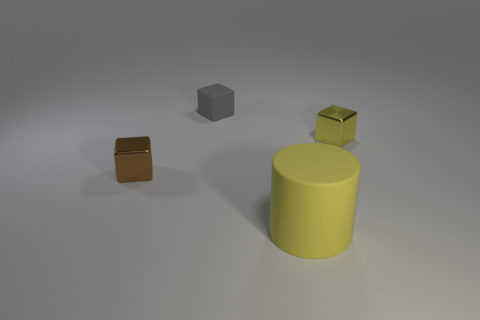Are there any other things that are the same size as the matte cylinder?
Keep it short and to the point. No. There is another rubber object that is the same shape as the small yellow object; what size is it?
Your answer should be very brief. Small. What is the yellow cylinder made of?
Keep it short and to the point. Rubber. What is the material of the yellow object in front of the tiny metallic thing to the left of the small metal thing to the right of the gray block?
Give a very brief answer. Rubber. Are there any other things that are the same shape as the big rubber object?
Ensure brevity in your answer.  No. There is another rubber object that is the same shape as the tiny brown object; what is its color?
Your answer should be compact. Gray. There is a small thing that is behind the yellow metal thing; is it the same color as the small block that is to the left of the rubber block?
Keep it short and to the point. No. Are there more small things on the left side of the small gray block than red metal objects?
Give a very brief answer. Yes. How many other things are there of the same size as the rubber cylinder?
Offer a terse response. 0. What number of small blocks are on the left side of the small yellow cube and behind the tiny brown block?
Your answer should be very brief. 1. 